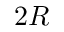<formula> <loc_0><loc_0><loc_500><loc_500>2 R</formula> 